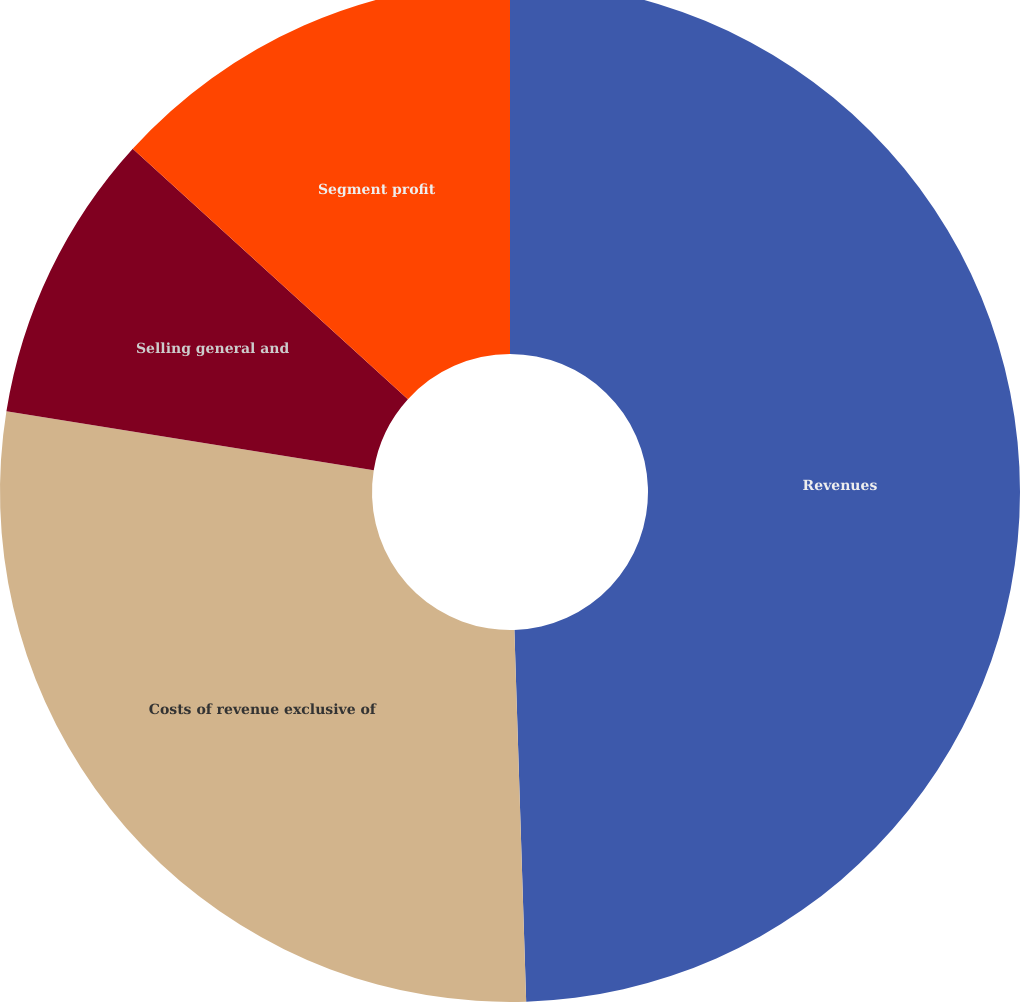Convert chart to OTSL. <chart><loc_0><loc_0><loc_500><loc_500><pie_chart><fcel>Revenues<fcel>Costs of revenue exclusive of<fcel>Selling general and<fcel>Segment profit<nl><fcel>49.49%<fcel>28.03%<fcel>9.22%<fcel>13.25%<nl></chart> 